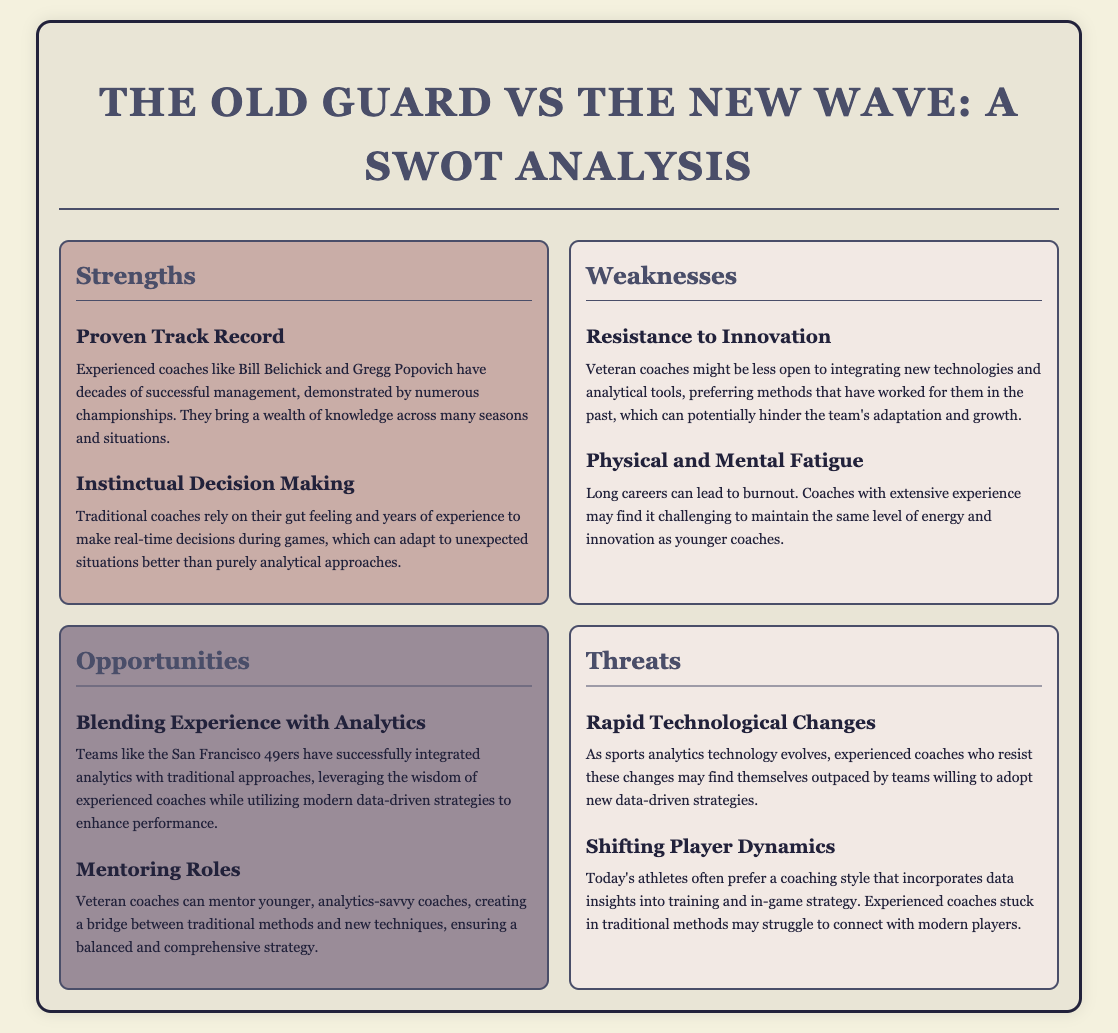What is the title of the document? The title of the document is elaborated in the header section of the rendered HTML, stating the focus of the SWOT analysis.
Answer: The Old Guard vs The New Wave: A SWOT Analysis Who are two experienced coaches mentioned? The text in the strengths section lists reputable coaches who exemplify experience, specifically highlighting their success.
Answer: Bill Belichick and Gregg Popovich What strength is related to decision-making? The strengths section discusses how traditional coaches utilize their experience to handle in-game situations effectively.
Answer: Instinctual Decision Making What opportunity involves blending methods? The opportunities section describes the successful integration of different approaches within certain teams.
Answer: Blending Experience with Analytics What is a threat related to technological changes? The threats section outlines the implications of evolving technology on the strategies employed by coaches.
Answer: Rapid Technological Changes What weakness pertains to energy levels? The weaknesses section identifies challenges related to the pressures of long careers in coaching.
Answer: Physical and Mental Fatigue What mentoring role can experienced coaches take? The opportunities section discusses how veteran coaches can support younger ones to bridge gaps in methodology.
Answer: Mentoring Roles What is a key reason modern players prefer data insights? The threats section indicates a shift in coaching preferences amongst today's athletes.
Answer: Shifting Player Dynamics 